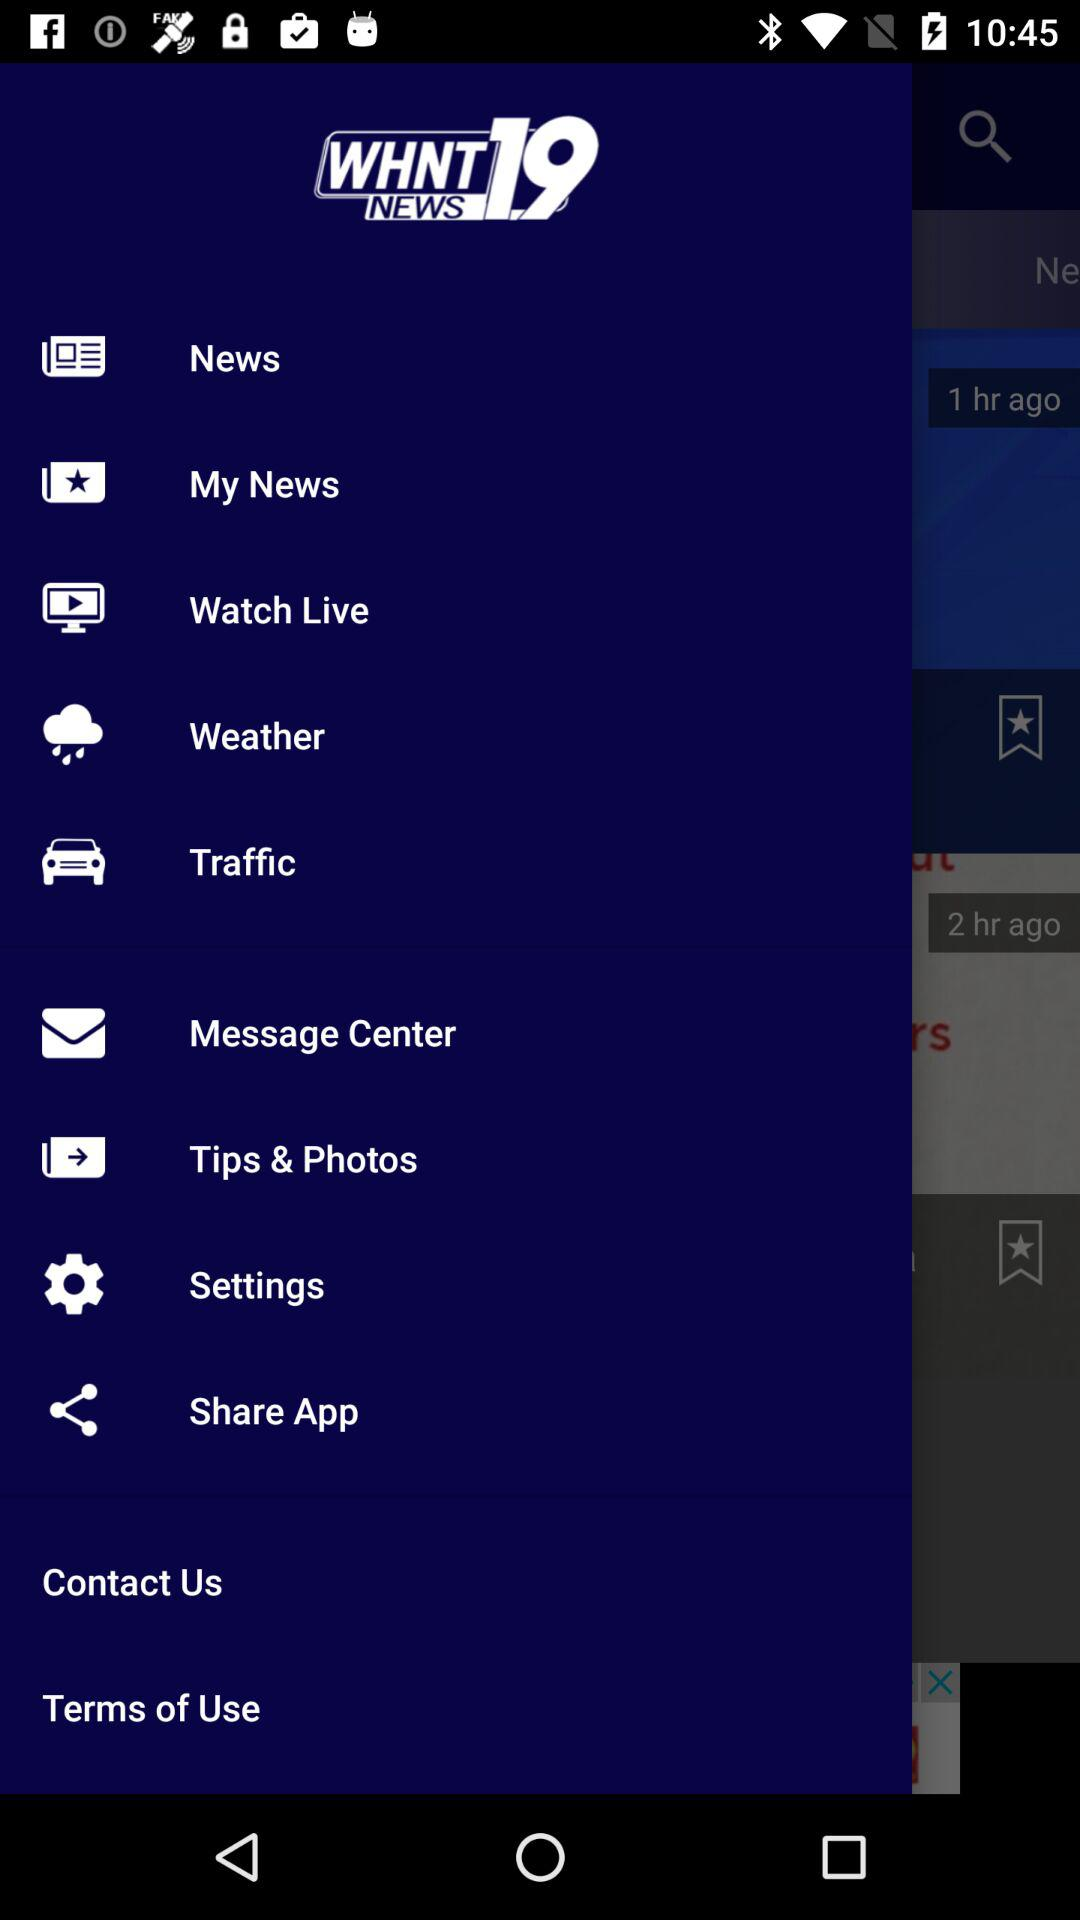What is the app name? The app name is "WHNT NEWS 19". 